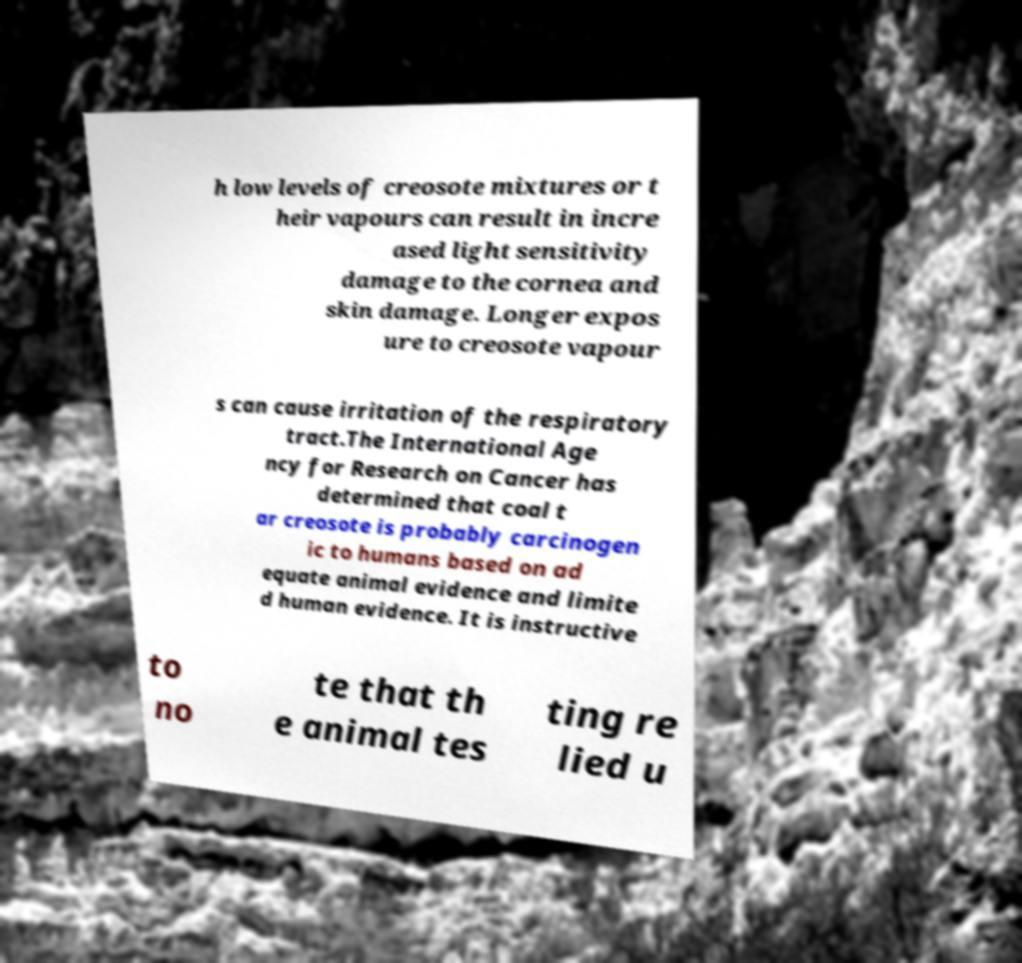Please read and relay the text visible in this image. What does it say? h low levels of creosote mixtures or t heir vapours can result in incre ased light sensitivity damage to the cornea and skin damage. Longer expos ure to creosote vapour s can cause irritation of the respiratory tract.The International Age ncy for Research on Cancer has determined that coal t ar creosote is probably carcinogen ic to humans based on ad equate animal evidence and limite d human evidence. It is instructive to no te that th e animal tes ting re lied u 